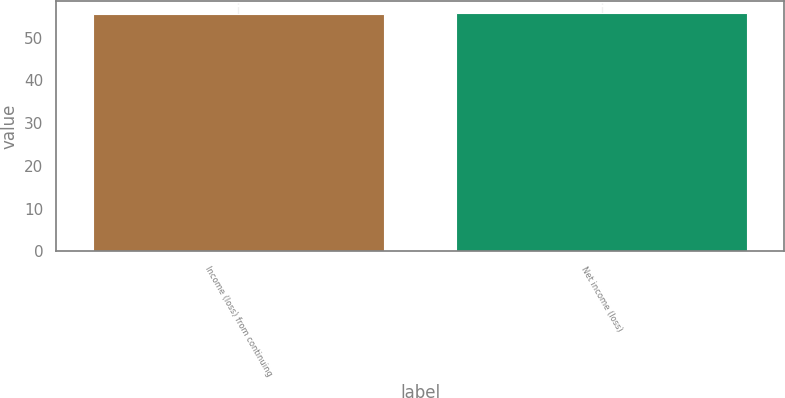<chart> <loc_0><loc_0><loc_500><loc_500><bar_chart><fcel>Income (loss) from continuing<fcel>Net income (loss)<nl><fcel>55.6<fcel>55.7<nl></chart> 